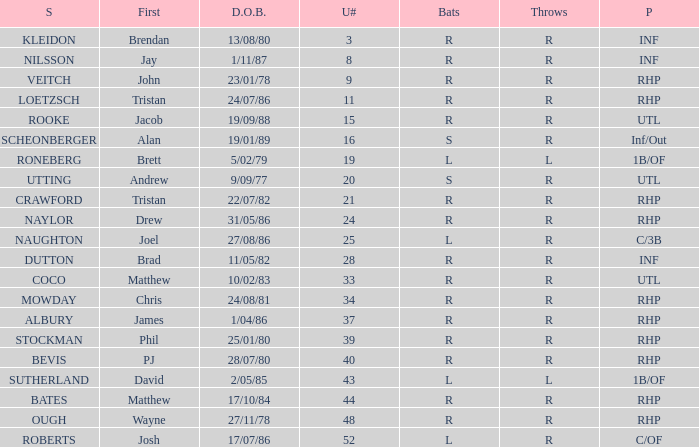How many Uni numbers have Bats of s, and a Position of utl? 1.0. 